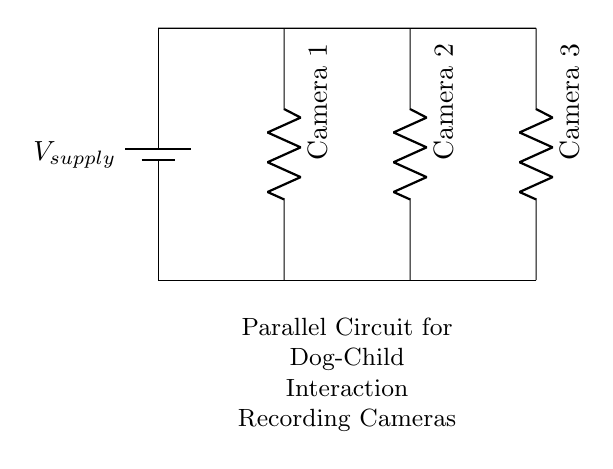What is the supply voltage in the circuit? The supply voltage is indicated by the battery label, which is commonly referred to as V_supply. The diagram doesn't provide a specific numerical value, leaving it as a variable.
Answer: V_supply How many camera systems are connected in parallel? The circuit diagram shows three cameras, labeled as Camera 1, Camera 2, and Camera 3, all connected in parallel to the supply line.
Answer: Three What kind of circuit is depicted in the diagram? The diagram displays a parallel circuit, which is characterized by each component being connected across the same voltage source independently, allowing for each camera to operate separately.
Answer: Parallel What happens if one camera fails in this circuit? If one camera fails in a parallel circuit, the others will continue to function because their connections to the voltage source are independent, thus maintaining the circuit's overall operation.
Answer: Others continue functioning What is the purpose of the resistors in this circuit? The resistors, represented by the symbols for each camera, might indicate the load that each camera presents to the power supply. They allow for current to flow through each camera system, which is essential for their operation during recording.
Answer: Indicate load 